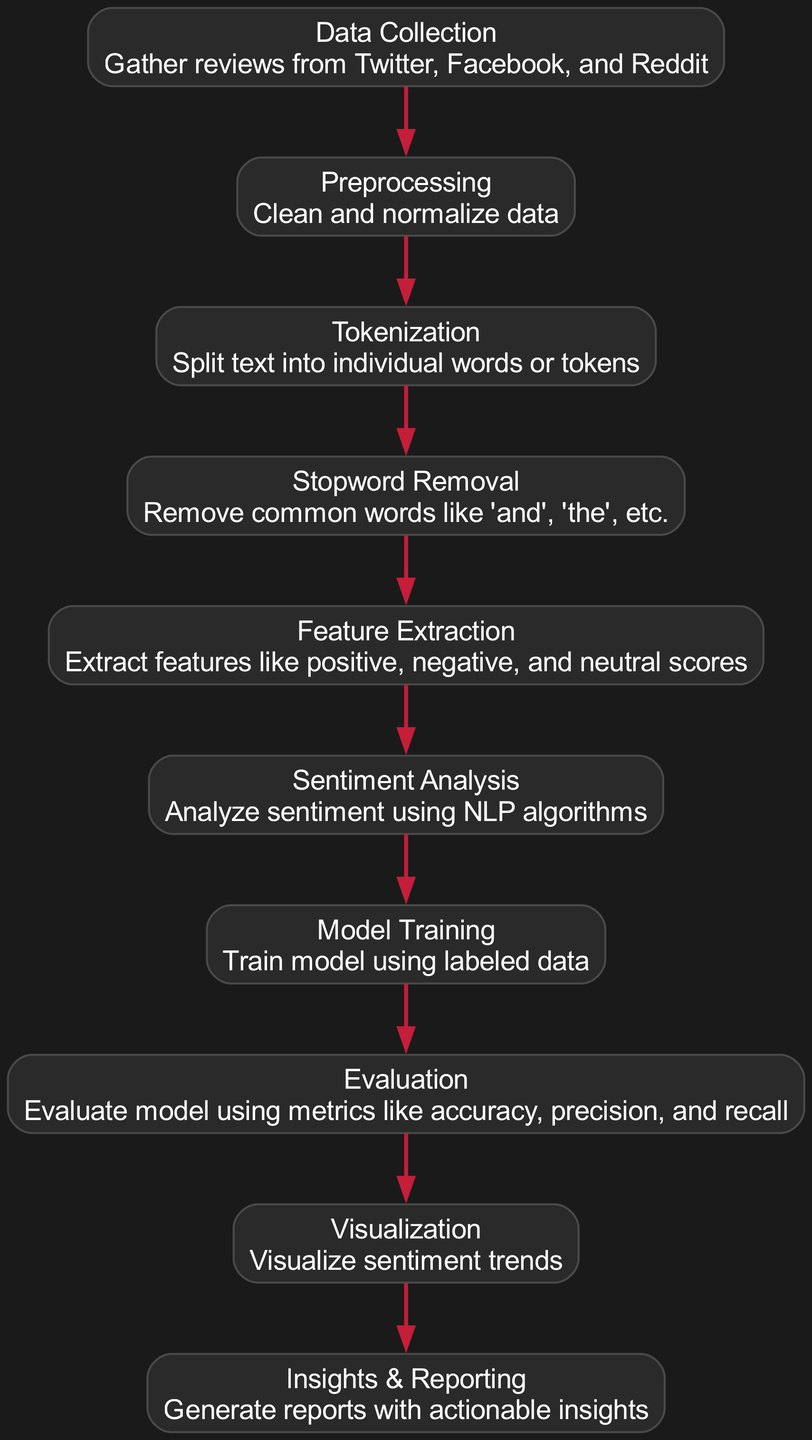What is the first step in the diagram? The first node in the diagram is "Data Collection," which represents the initial phase where reviews are gathered from various social media platforms.
Answer: Data Collection How many nodes are there in the diagram? By counting all the nodes listed in the data section, we find there are ten unique steps involved in the sentiment analysis process.
Answer: Ten Which phase comes after Stopword Removal? The flow of the diagram indicates that the next step after "Stopword Removal" is "Feature Extraction." This means that once common words are removed, relevant features are then extracted from the data.
Answer: Feature Extraction What is the last phase before Insights & Reporting? The last step preceding "Insights & Reporting" is "Visualization." This step involves visualizing sentiment trends that were identified in the analysis, which feeds into generating final insights.
Answer: Visualization How many edges connect the nodes in the diagram? By examining the connections between nodes, we can determine that there are nine edges representing the relationships and transitions from one step to another in the pipeline.
Answer: Nine What type of analysis is performed after Feature Extraction? The diagram shows that "Sentiment Analysis" is performed right after "Feature Extraction," indicating the analysis of the sentiment associated with reviews following feature extraction.
Answer: Sentiment Analysis What does the Evaluation phase assess? The "Evaluation" phase assesses the model's performance through various metrics, including accuracy, precision, and recall, to ensure its effectiveness in understanding sentiment from fan reviews.
Answer: Model performance metrics What is the purpose of the Tokenization step? The "Tokenization" step is critical as it splits the collected text into individual words or tokens, preparing the data for further processing in the sentiment analysis pipeline.
Answer: Split text into tokens Which node precedes Model Training? According to the diagram, the node that comes immediately before "Model Training" is "Sentiment Analysis," highlighting the order of operations leading to training the model.
Answer: Sentiment Analysis 